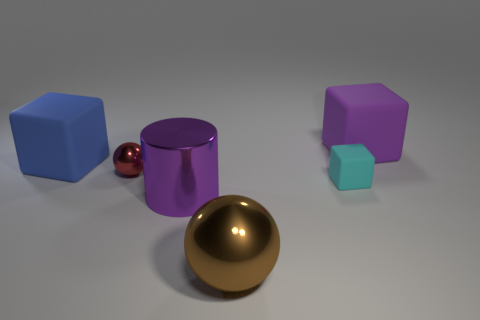Subtract 1 blocks. How many blocks are left? 2 Add 3 big spheres. How many objects exist? 9 Subtract all large rubber cubes. How many cubes are left? 1 Subtract all brown spheres. How many spheres are left? 1 Subtract all cylinders. How many objects are left? 5 Subtract all red things. Subtract all green matte cylinders. How many objects are left? 5 Add 4 big brown metal objects. How many big brown metal objects are left? 5 Add 6 purple matte cubes. How many purple matte cubes exist? 7 Subtract 1 purple cylinders. How many objects are left? 5 Subtract all blue cylinders. Subtract all yellow cubes. How many cylinders are left? 1 